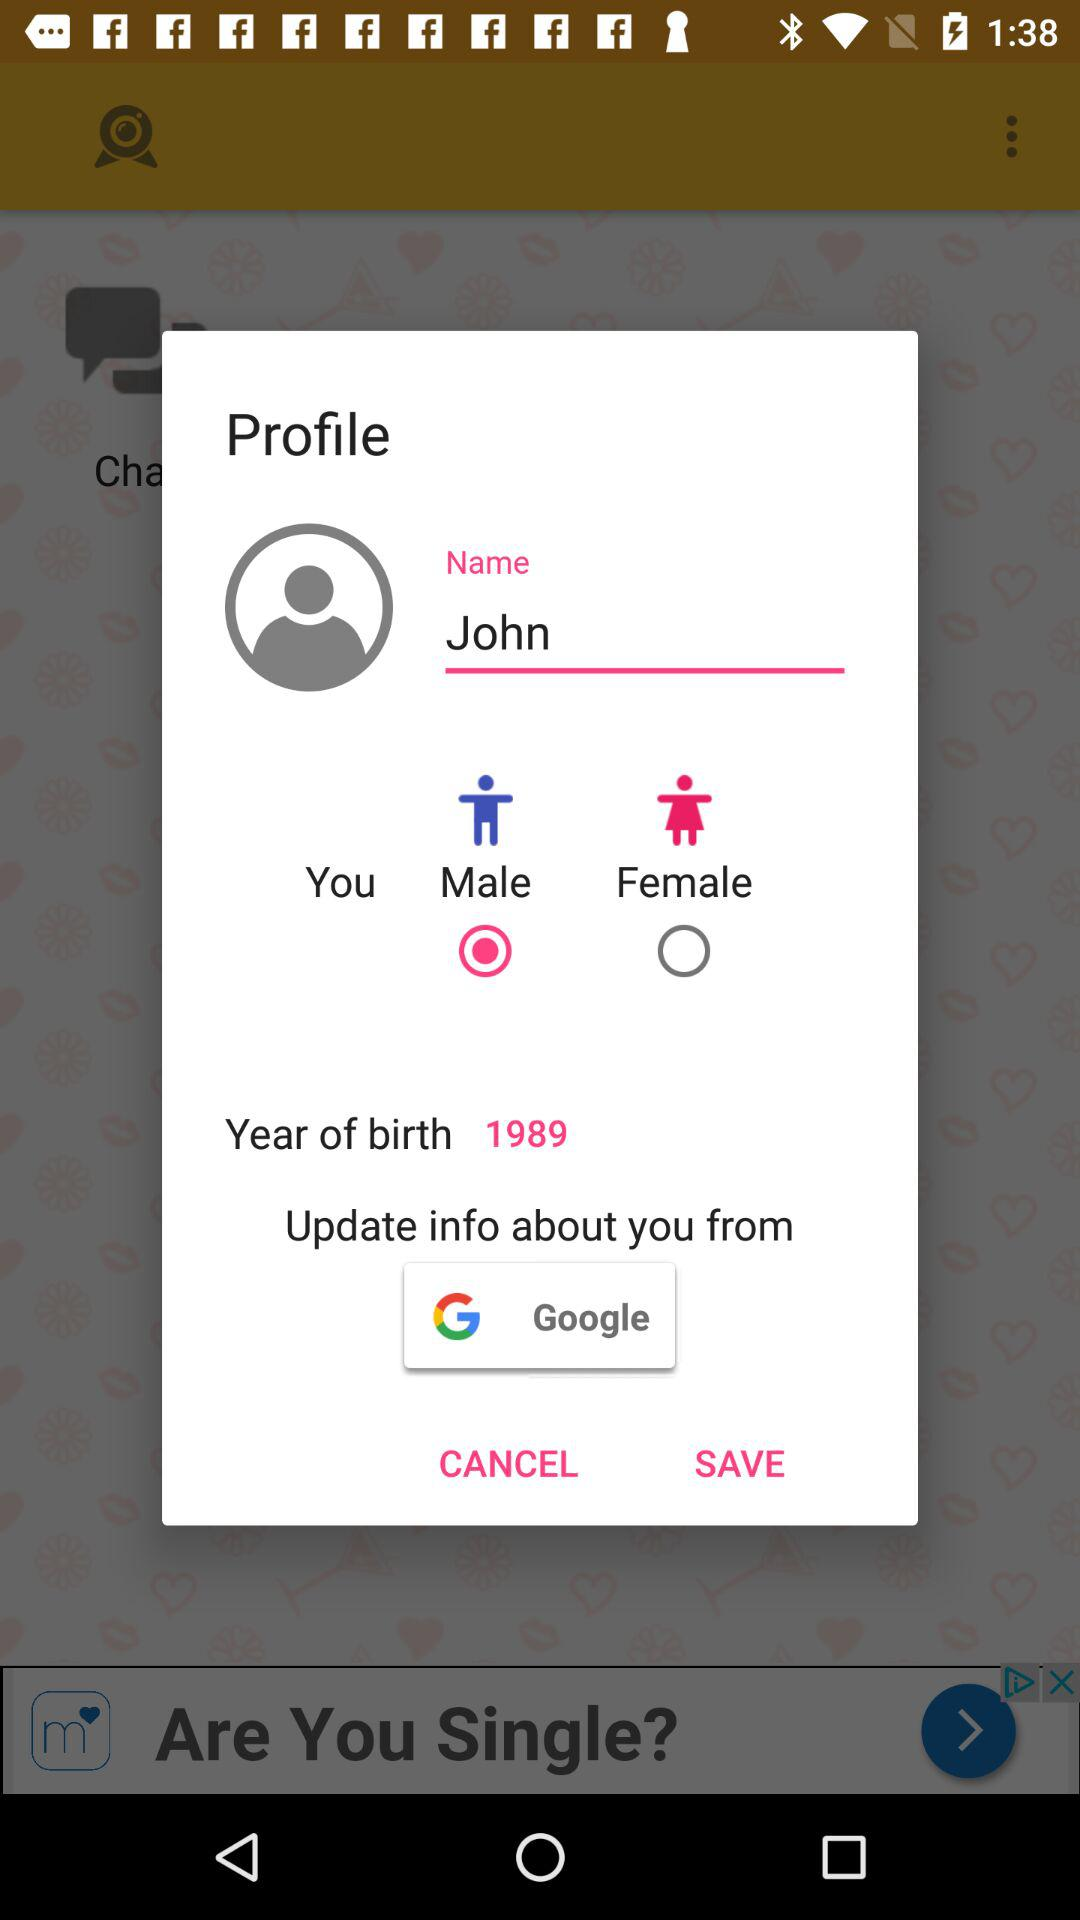What is the gender of the person? The person is a male. 